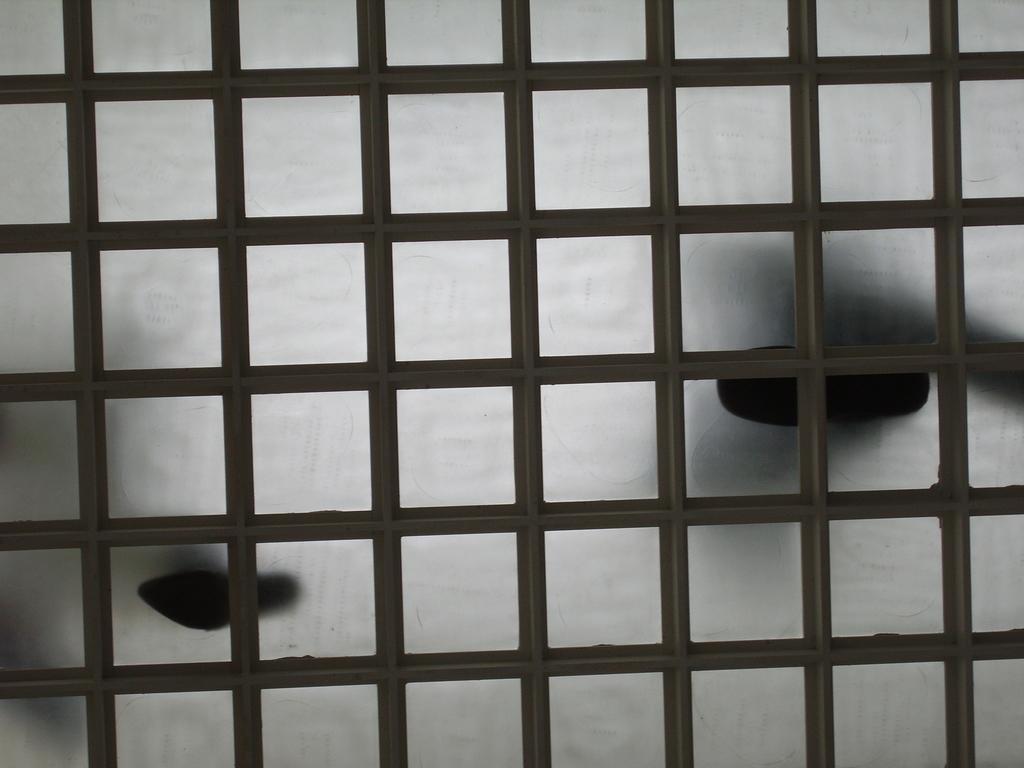In one or two sentences, can you explain what this image depicts? In this image I can see the glass floor which is white and black in color. It looks like two persons are standing on it. 